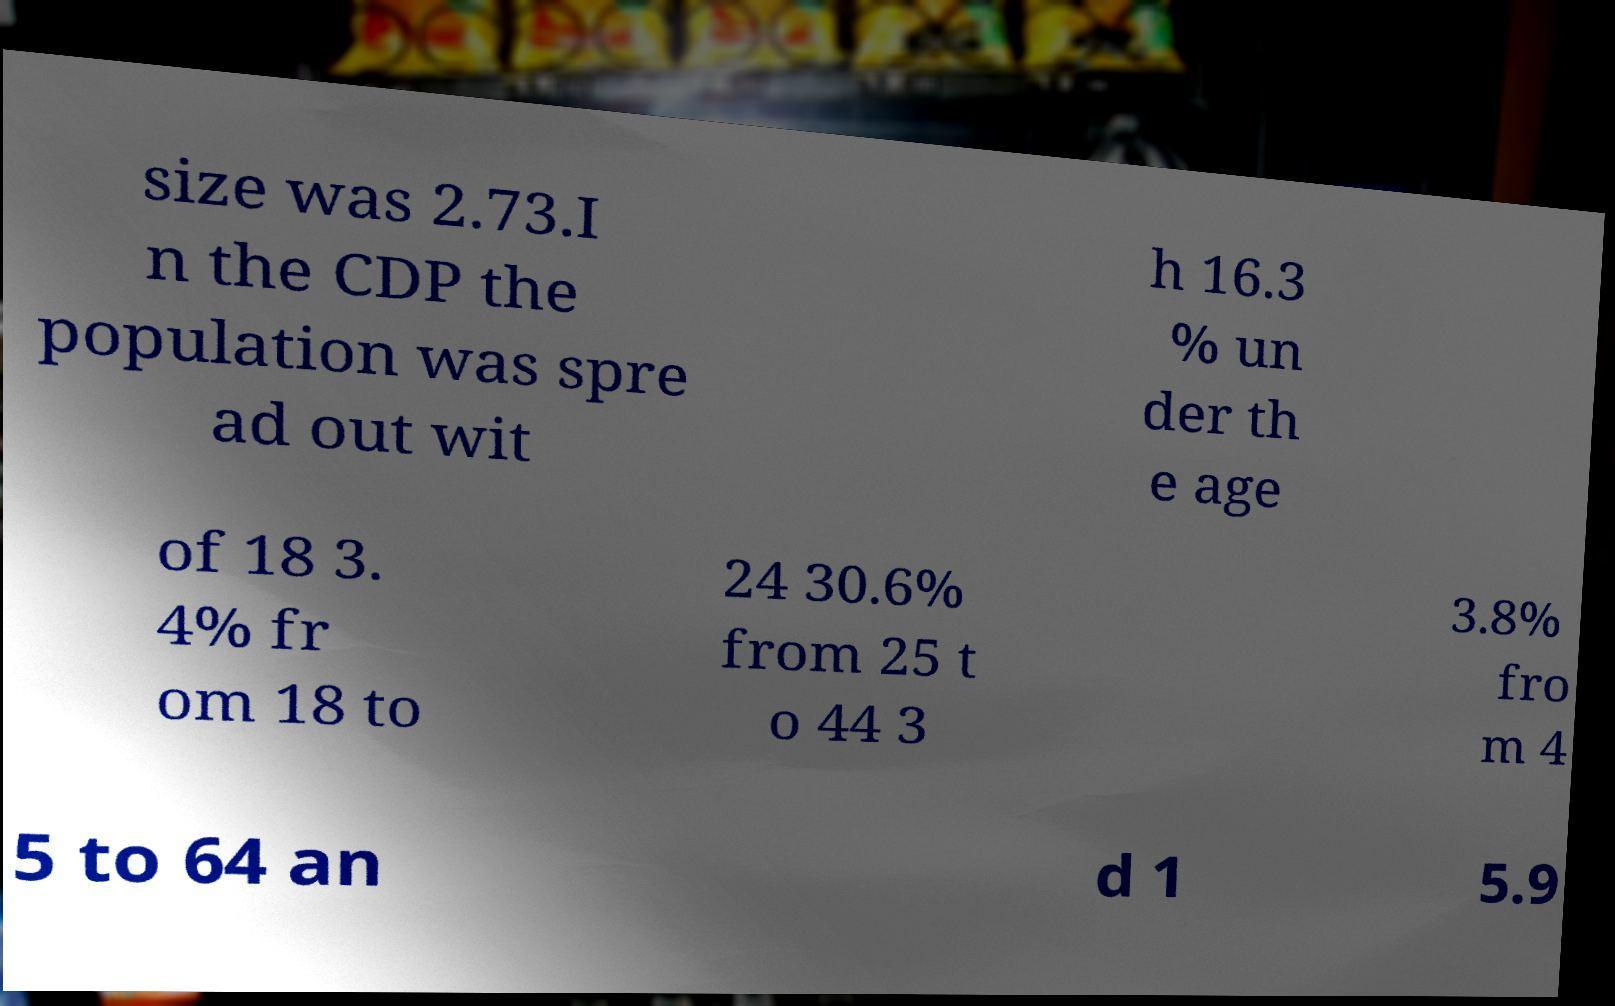What messages or text are displayed in this image? I need them in a readable, typed format. size was 2.73.I n the CDP the population was spre ad out wit h 16.3 % un der th e age of 18 3. 4% fr om 18 to 24 30.6% from 25 t o 44 3 3.8% fro m 4 5 to 64 an d 1 5.9 